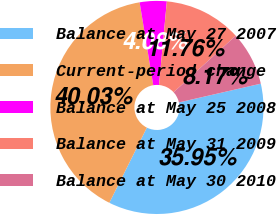Convert chart to OTSL. <chart><loc_0><loc_0><loc_500><loc_500><pie_chart><fcel>Balance at May 27 2007<fcel>Current-period change<fcel>Balance at May 25 2008<fcel>Balance at May 31 2009<fcel>Balance at May 30 2010<nl><fcel>35.95%<fcel>40.03%<fcel>4.08%<fcel>11.76%<fcel>8.17%<nl></chart> 